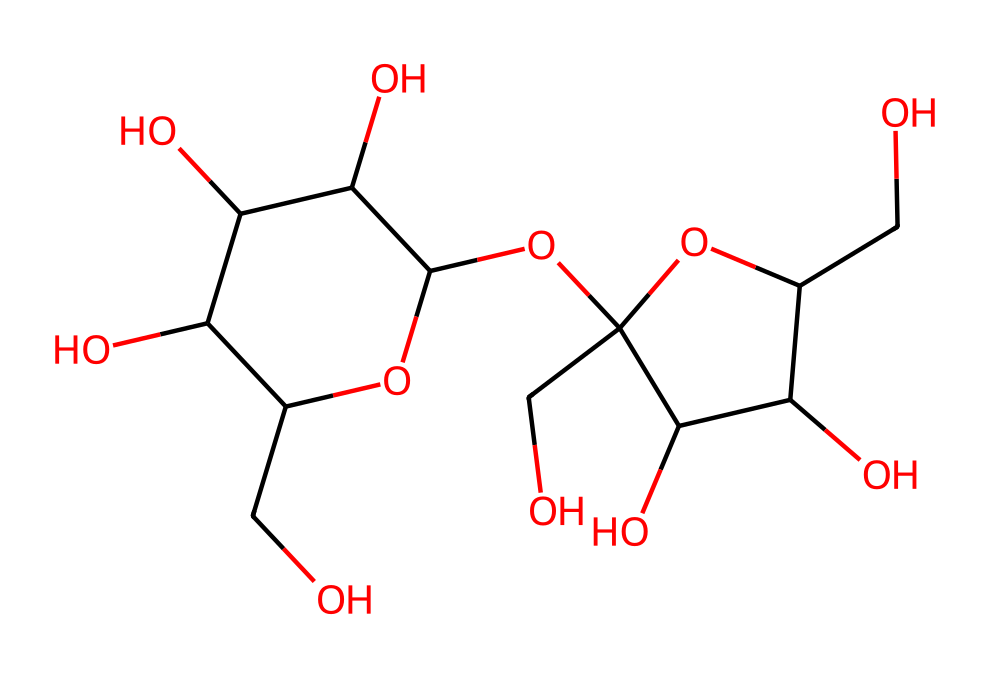What is the name of this chemical? The provided SMILES representation corresponds to sucrose, which is a common non-electrolyte sugar. The structure and connectivity of the atoms in the SMILES indicates that it is a carbohydrate.
Answer: sucrose How many carbon atoms are in sucrose? By analyzing the SMILES structure, we can count the number of carbon (C) atoms present. There are 12 carbon atoms indicated in the structure.
Answer: 12 What type of chemical is sucrose categorized as? Sucrose is categorized as a non-electrolyte because it does not dissociate into ions in solution. This is evident from its structure, consisting solely of carbon, hydrogen, and oxygen.
Answer: non-electrolyte How many hydroxyl (–OH) groups are present in sucrose? In the sucrose structure, we can identify the presence of hydroxyl groups (–OH) by looking for oxygen atoms bonded to hydrogen. There are 6 hydroxyl groups in total based on the structure.
Answer: 6 What is the impact of sucrose’s non-electrolyte nature on its use in snacks? Sucrose being a non-electrolyte means it does not conduct electricity in solution, affecting its use in snacks. This property allows it to simply provide sweetness without contributing to electrical conductivity in snack formulations.
Answer: provides sweetness What structural feature indicates that sucrose is a disaccharide? The presence of two monosaccharide units linked by a glycosidic bond indicates that sucrose is a disaccharide. By analyzing the connections in the structure, it's clear that two sugar units combine to form sucrose.
Answer: two monosaccharide units Is sucrose soluble in water? Yes, sucrose is soluble in water, which is a characteristic of most non-electrolytes. The polarity of the hydroxyl groups in its structure facilitates hydrogen bonding with water molecules, promoting solubility.
Answer: yes 